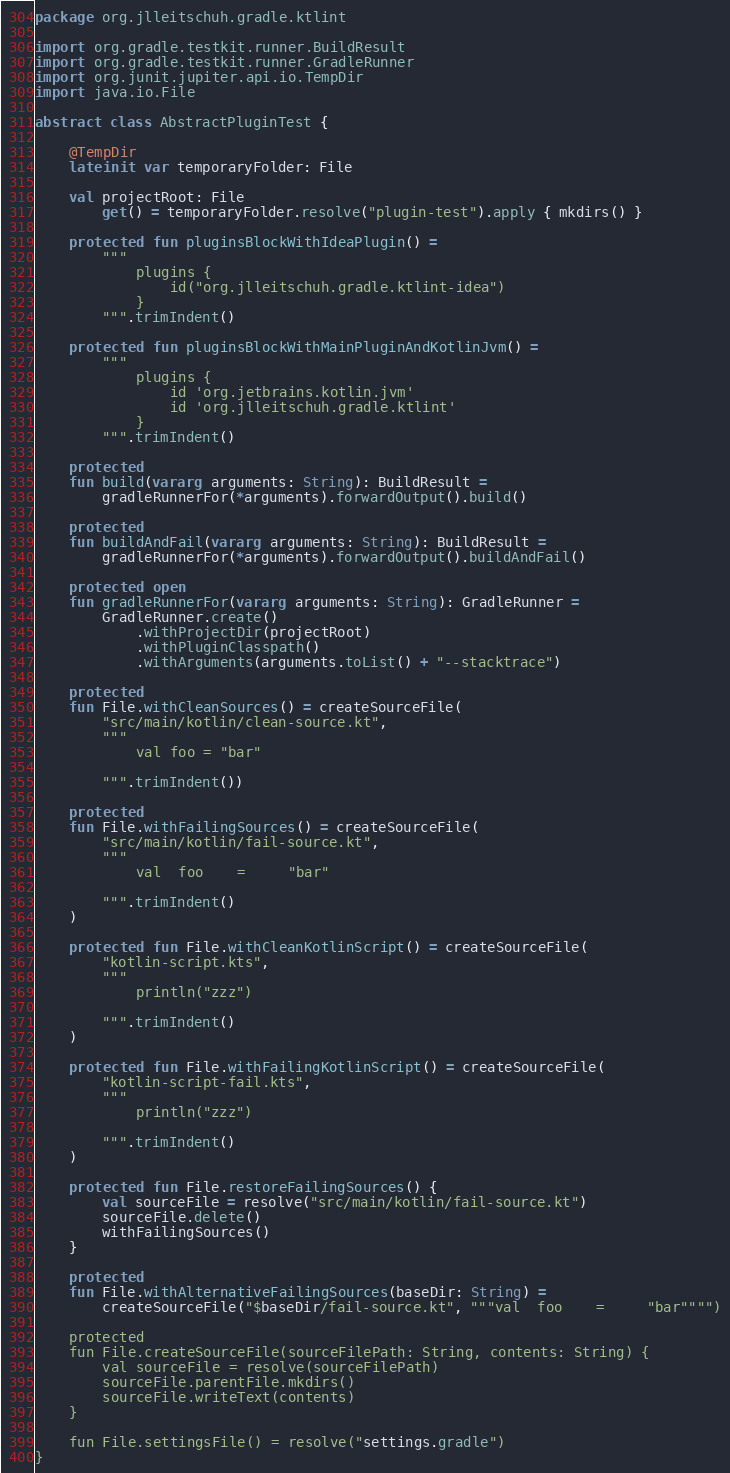<code> <loc_0><loc_0><loc_500><loc_500><_Kotlin_>package org.jlleitschuh.gradle.ktlint

import org.gradle.testkit.runner.BuildResult
import org.gradle.testkit.runner.GradleRunner
import org.junit.jupiter.api.io.TempDir
import java.io.File

abstract class AbstractPluginTest {

    @TempDir
    lateinit var temporaryFolder: File

    val projectRoot: File
        get() = temporaryFolder.resolve("plugin-test").apply { mkdirs() }

    protected fun pluginsBlockWithIdeaPlugin() =
        """
            plugins {
                id("org.jlleitschuh.gradle.ktlint-idea")
            }
        """.trimIndent()

    protected fun pluginsBlockWithMainPluginAndKotlinJvm() =
        """
            plugins {
                id 'org.jetbrains.kotlin.jvm'
                id 'org.jlleitschuh.gradle.ktlint'
            }
        """.trimIndent()

    protected
    fun build(vararg arguments: String): BuildResult =
        gradleRunnerFor(*arguments).forwardOutput().build()

    protected
    fun buildAndFail(vararg arguments: String): BuildResult =
        gradleRunnerFor(*arguments).forwardOutput().buildAndFail()

    protected open
    fun gradleRunnerFor(vararg arguments: String): GradleRunner =
        GradleRunner.create()
            .withProjectDir(projectRoot)
            .withPluginClasspath()
            .withArguments(arguments.toList() + "--stacktrace")

    protected
    fun File.withCleanSources() = createSourceFile(
        "src/main/kotlin/clean-source.kt",
        """
            val foo = "bar"
            
        """.trimIndent())

    protected
    fun File.withFailingSources() = createSourceFile(
        "src/main/kotlin/fail-source.kt",
        """
            val  foo    =     "bar"
            
        """.trimIndent()
    )

    protected fun File.withCleanKotlinScript() = createSourceFile(
        "kotlin-script.kts",
        """
            println("zzz")
            
        """.trimIndent()
    )

    protected fun File.withFailingKotlinScript() = createSourceFile(
        "kotlin-script-fail.kts",
        """
            println("zzz") 
            
        """.trimIndent()
    )

    protected fun File.restoreFailingSources() {
        val sourceFile = resolve("src/main/kotlin/fail-source.kt")
        sourceFile.delete()
        withFailingSources()
    }

    protected
    fun File.withAlternativeFailingSources(baseDir: String) =
        createSourceFile("$baseDir/fail-source.kt", """val  foo    =     "bar"""")

    protected
    fun File.createSourceFile(sourceFilePath: String, contents: String) {
        val sourceFile = resolve(sourceFilePath)
        sourceFile.parentFile.mkdirs()
        sourceFile.writeText(contents)
    }

    fun File.settingsFile() = resolve("settings.gradle")
}
</code> 